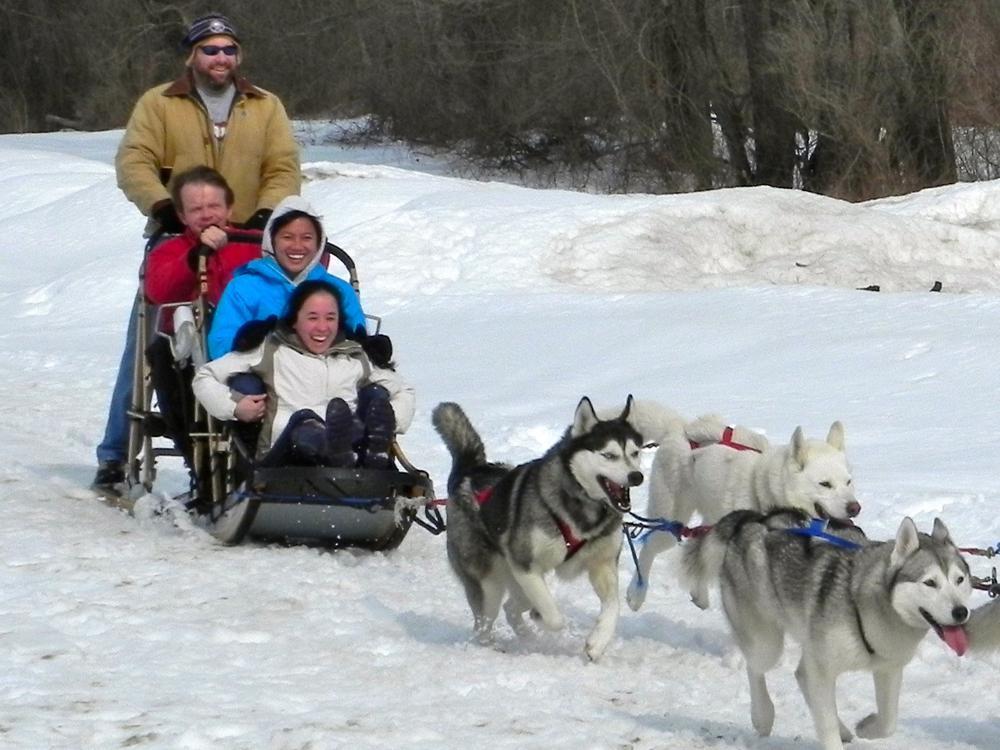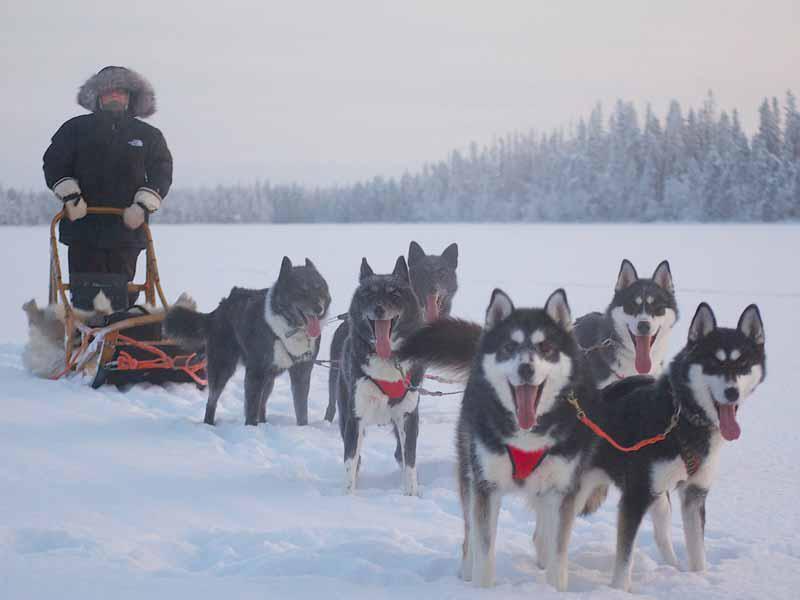The first image is the image on the left, the second image is the image on the right. Analyze the images presented: Is the assertion "There are at least three people in the sled in one of the images." valid? Answer yes or no. Yes. The first image is the image on the left, the second image is the image on the right. Assess this claim about the two images: "There are no more than three sledding dogs in the right image.". Correct or not? Answer yes or no. No. 